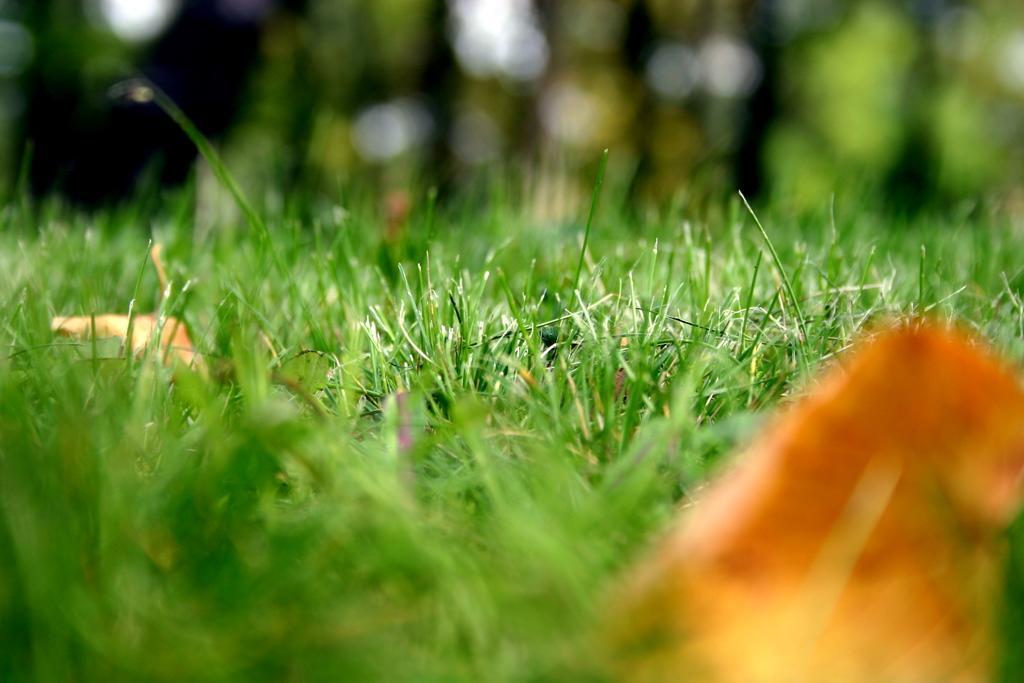In one or two sentences, can you explain what this image depicts? This picture contains grass and dried leaves. At the bottom of the picture, it is in green and orange color. In the background, it is green in color. It is blurred in the background. 